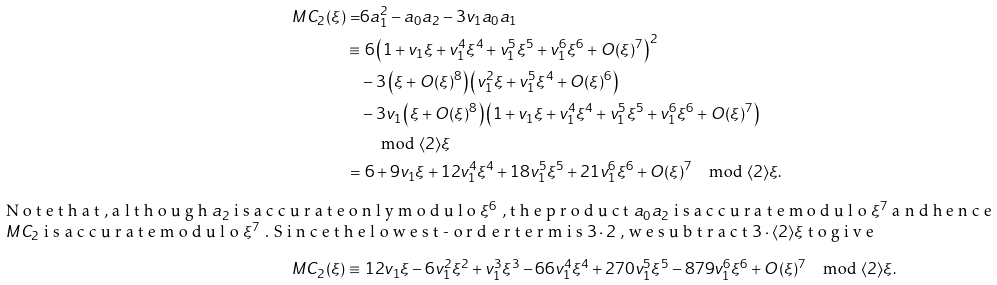<formula> <loc_0><loc_0><loc_500><loc_500>M C _ { 2 } ( \xi ) = & 6 a _ { 1 } ^ { 2 } - a _ { 0 } a _ { 2 } - 3 v _ { 1 } a _ { 0 } a _ { 1 } \\ \equiv & \ 6 \left ( 1 + v _ { 1 } \xi + v _ { 1 } ^ { 4 } \xi ^ { 4 } + v _ { 1 } ^ { 5 } \xi ^ { 5 } + v _ { 1 } ^ { 6 } \xi ^ { 6 } + O ( \xi ) ^ { 7 } \right ) ^ { 2 } \\ & - 3 \left ( \xi + O ( \xi ) ^ { 8 } \right ) \left ( v _ { 1 } ^ { 2 } \xi + v _ { 1 } ^ { 5 } \xi ^ { 4 } + O ( \xi ) ^ { 6 } \right ) \\ & - 3 v _ { 1 } \left ( \xi + O ( \xi ) ^ { 8 } \right ) \left ( 1 + v _ { 1 } \xi + v _ { 1 } ^ { 4 } \xi ^ { 4 } + v _ { 1 } ^ { 5 } \xi ^ { 5 } + v _ { 1 } ^ { 6 } \xi ^ { 6 } + O ( \xi ) ^ { 7 } \right ) \\ & \quad \text { mod } \langle 2 \rangle \xi \\ = & \ 6 + 9 v _ { 1 } \xi + 1 2 v _ { 1 } ^ { 4 } \xi ^ { 4 } + 1 8 v _ { 1 } ^ { 5 } \xi ^ { 5 } + 2 1 v _ { 1 } ^ { 6 } \xi ^ { 6 } + O ( \xi ) ^ { 7 } \quad \text {mod } \langle 2 \rangle \xi . \intertext { N o t e t h a t , a l t h o u g h $ a _ { 2 } $ i s a c c u r a t e o n l y m o d u l o $ \xi ^ { 6 } $ , t h e p r o d u c t $ a _ { 0 } a _ { 2 } $ i s a c c u r a t e m o d u l o $ \xi ^ { 7 } $ a n d h e n c e $ M C _ { 2 } $ i s a c c u r a t e m o d u l o $ \xi ^ { 7 } $ . S i n c e t h e l o w e s t - o r d e r t e r m i s $ 3 \cdot 2 $ , w e s u b t r a c t $ 3 \cdot \langle 2 \rangle \xi $ t o g i v e } M C _ { 2 } ( \xi ) \equiv & \ 1 2 v _ { 1 } \xi - 6 v _ { 1 } ^ { 2 } \xi ^ { 2 } + v _ { 1 } ^ { 3 } \xi ^ { 3 } - 6 6 v _ { 1 } ^ { 4 } \xi ^ { 4 } + 2 7 0 v _ { 1 } ^ { 5 } \xi ^ { 5 } - 8 7 9 v _ { 1 } ^ { 6 } \xi ^ { 6 } + O ( \xi ) ^ { 7 } \quad \text {mod } \langle 2 \rangle \xi .</formula> 